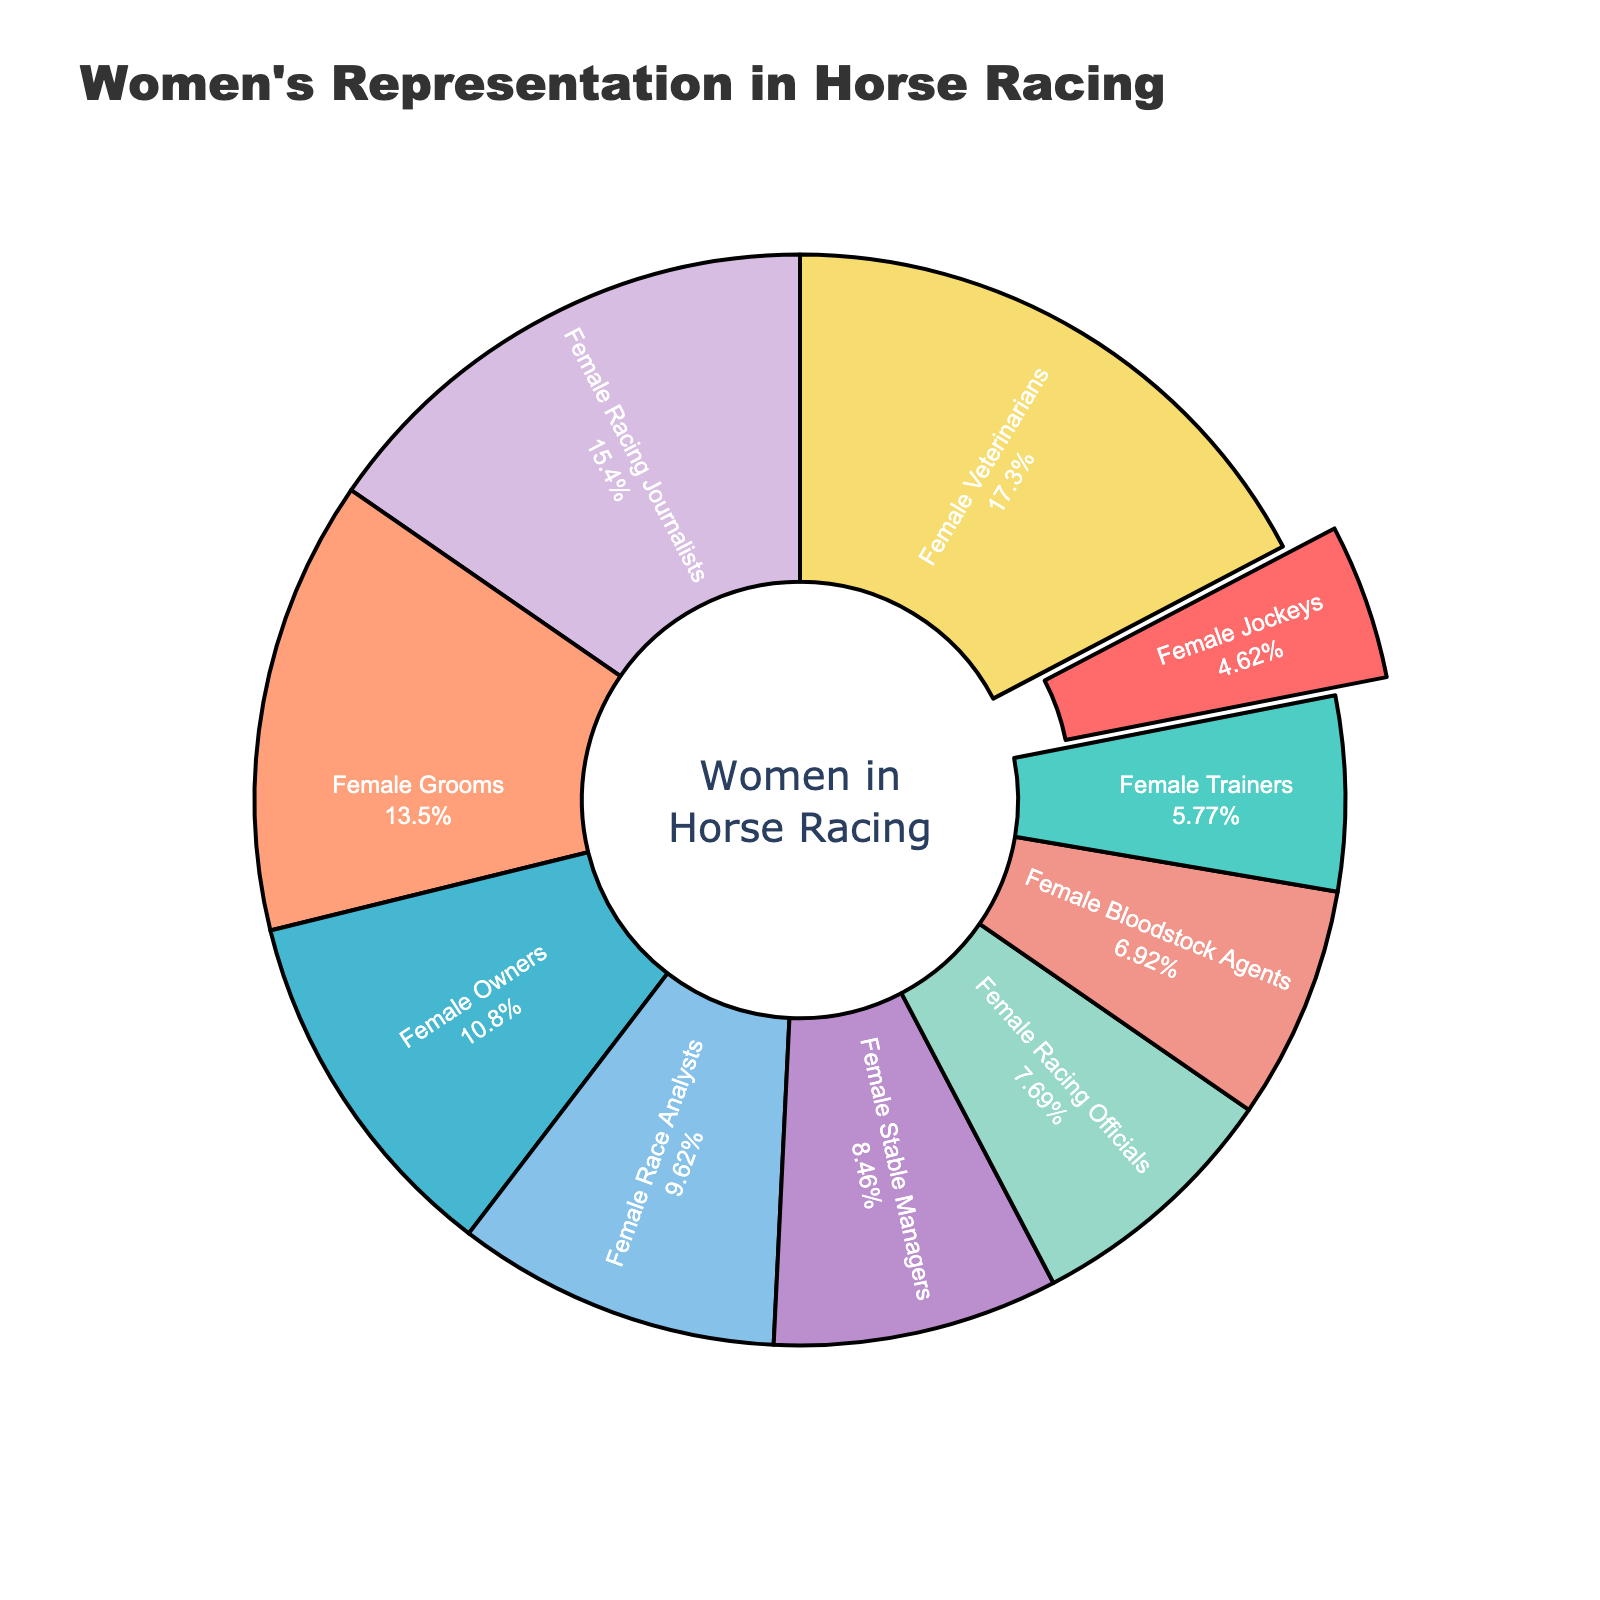Which role has the highest percentage of women? The segment for "Female Veterinarians" has the largest proportion of the pie chart, indicating that it has the highest percentage of women.
Answer: Female Veterinarians Which has a higher percentage: Female Racing Officials or Female Race Analysts? By comparing the sizes of the segments, we can see that "Female Race Analysts" (25%) is larger than "Female Racing Officials" (20%).
Answer: Female Race Analysts What is the difference in percentage between the role with the highest and the role with the lowest representation of women? The highest percentage is "Female Veterinarians" (45%) and the lowest is "Female Jockeys" (12%). The difference is 45% - 12% = 33%.
Answer: 33% How do Female Trainers compare to Female Stable Managers in terms of percentage? "Female Stable Managers" are at 22%, while "Female Trainers" are at 15%. Female Stable Managers have a higher percentage than Female Trainers.
Answer: Female Stable Managers What is the sum of the percentages of Female Owners and Female Grooms? The percentage for "Female Owners" is 28% and for "Female Grooms" is 35%. Sum them up: 28% + 35% = 63%.
Answer: 63% Which categories fall within the 20% to 30% range and how many are there? The categories "Female Racing Officials" (20%), "Female Stable Managers" (22%), "Female Bloodstock Agents" (18%), and "Female Race Analysts" (25%) are within the range of 20% to 30%. Counting these, there are four categories.
Answer: Four categories What's the approximate total percentage for the three least represented roles? The three least represented roles are "Female Jockeys" (12%), "Female Trainers" (15%), and "Female Bloodstock Agents" (18%). Summing them: 12% + 15% + 18% = 45%.
Answer: 45% Which segment is pulled out from the pie chart, and why do you think it's highlighted? The segment for "Female Jockeys" is pulled out. It is likely highlighted to emphasize its importance, especially given the historically low representation of women in that role.
Answer: Female Jockeys 